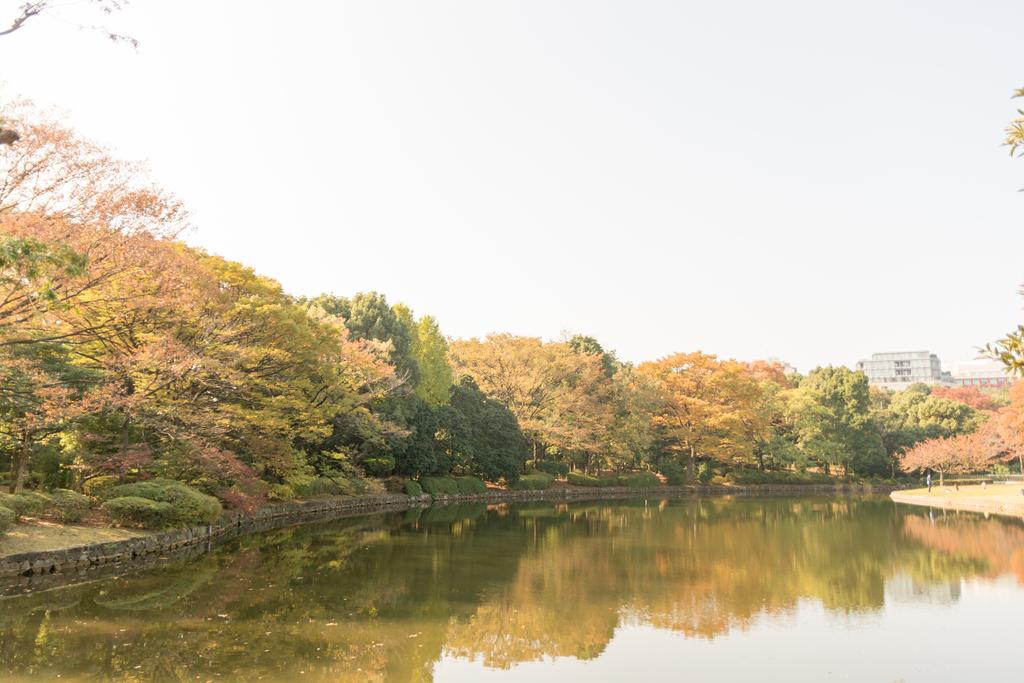What type of natural body of water is present in the image? There is a lake in the picture. What type of vegetation can be seen in the image? There are trees and plants in the picture. What type of structure is visible in the background of the image? There is a building in the background of the picture. What is the condition of the sky in the image? The sky is clear in the picture. How many sisters are sitting by the lake in the image? There are no sisters present in the image; it only features a lake, trees, plants, a building, and a clear sky. What type of zipper can be seen on the trees in the image? There are no zippers present on the trees or any other elements in the image. 